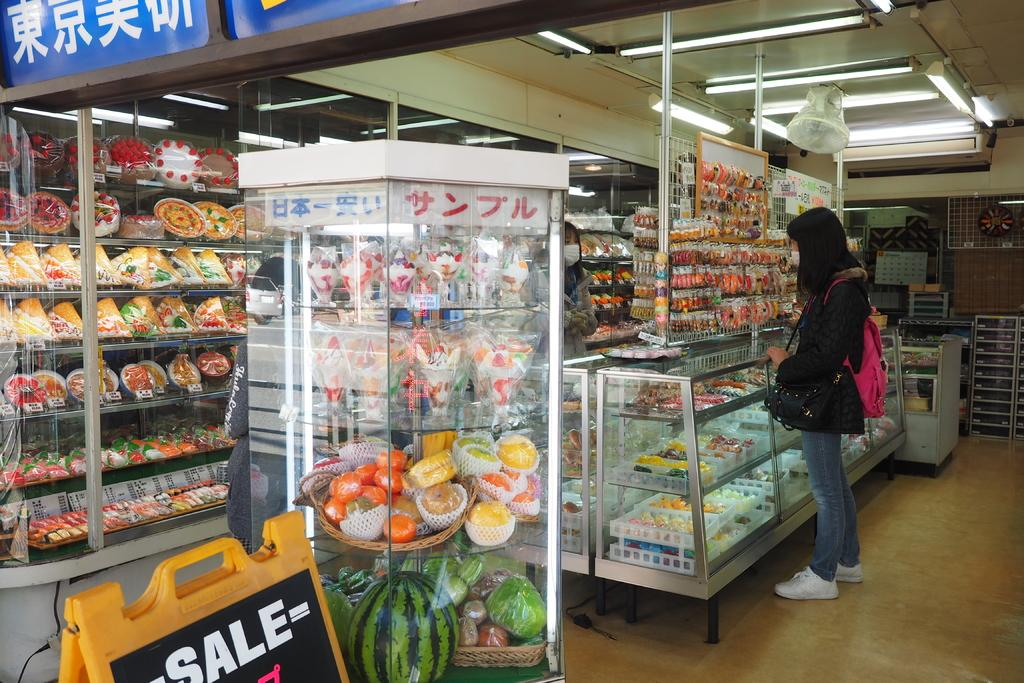<image>
Relay a brief, clear account of the picture shown. A signin grocery store saying there is a sale . 